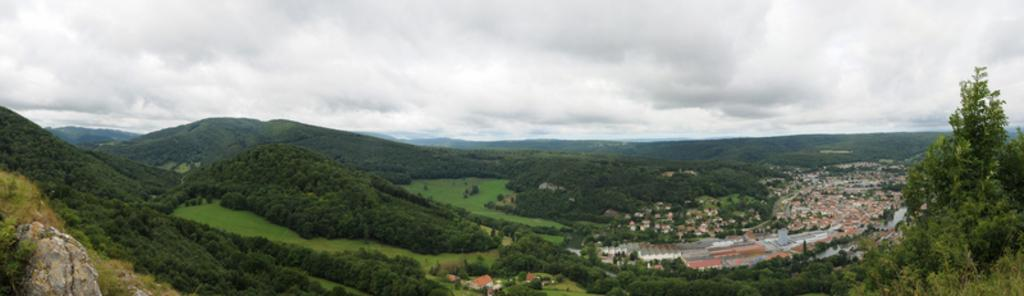What type of structures can be seen in the image? There are buildings in the image. What natural elements are present in the image? There are many trees and mountains visible in the image. What can be seen in the background of the image? There are clouds and the sky visible in the background of the image. Where is the bucket of jam located in the image? There is no bucket of jam present in the image. What type of base is supporting the mountains in the image? The mountains are not supported by a base; they are natural landforms. 